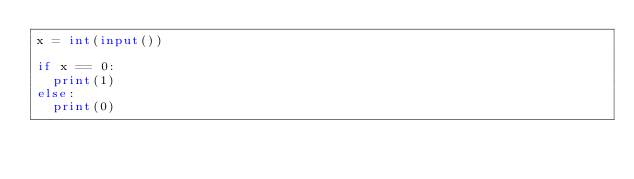<code> <loc_0><loc_0><loc_500><loc_500><_Python_>x = int(input())

if x == 0:
  print(1)
else:
  print(0)</code> 